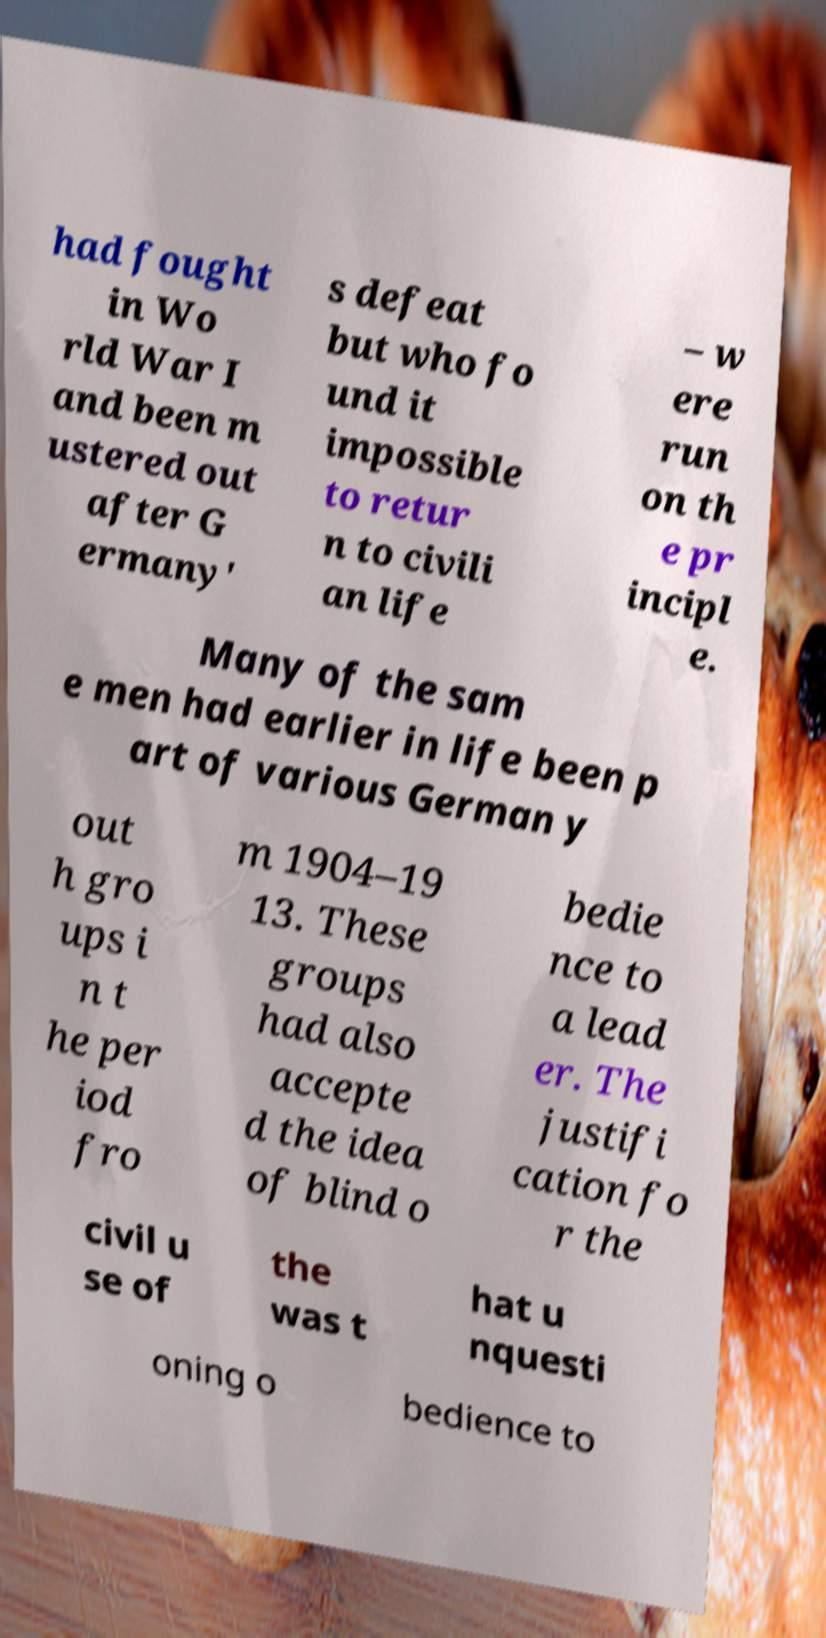For documentation purposes, I need the text within this image transcribed. Could you provide that? had fought in Wo rld War I and been m ustered out after G ermany' s defeat but who fo und it impossible to retur n to civili an life – w ere run on th e pr incipl e. Many of the sam e men had earlier in life been p art of various German y out h gro ups i n t he per iod fro m 1904–19 13. These groups had also accepte d the idea of blind o bedie nce to a lead er. The justifi cation fo r the civil u se of the was t hat u nquesti oning o bedience to 